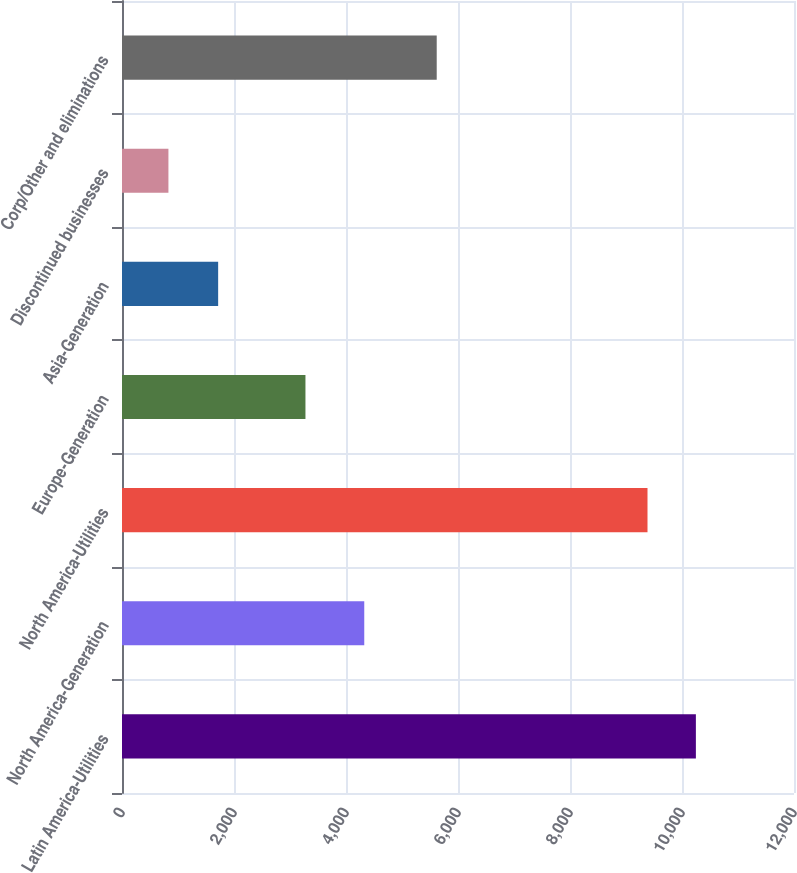Convert chart to OTSL. <chart><loc_0><loc_0><loc_500><loc_500><bar_chart><fcel>Latin America-Utilities<fcel>North America-Generation<fcel>North America-Utilities<fcel>Europe-Generation<fcel>Asia-Generation<fcel>Discontinued businesses<fcel>Corp/Other and eliminations<nl><fcel>10247.9<fcel>4326<fcel>9384<fcel>3276<fcel>1717<fcel>829<fcel>5620<nl></chart> 